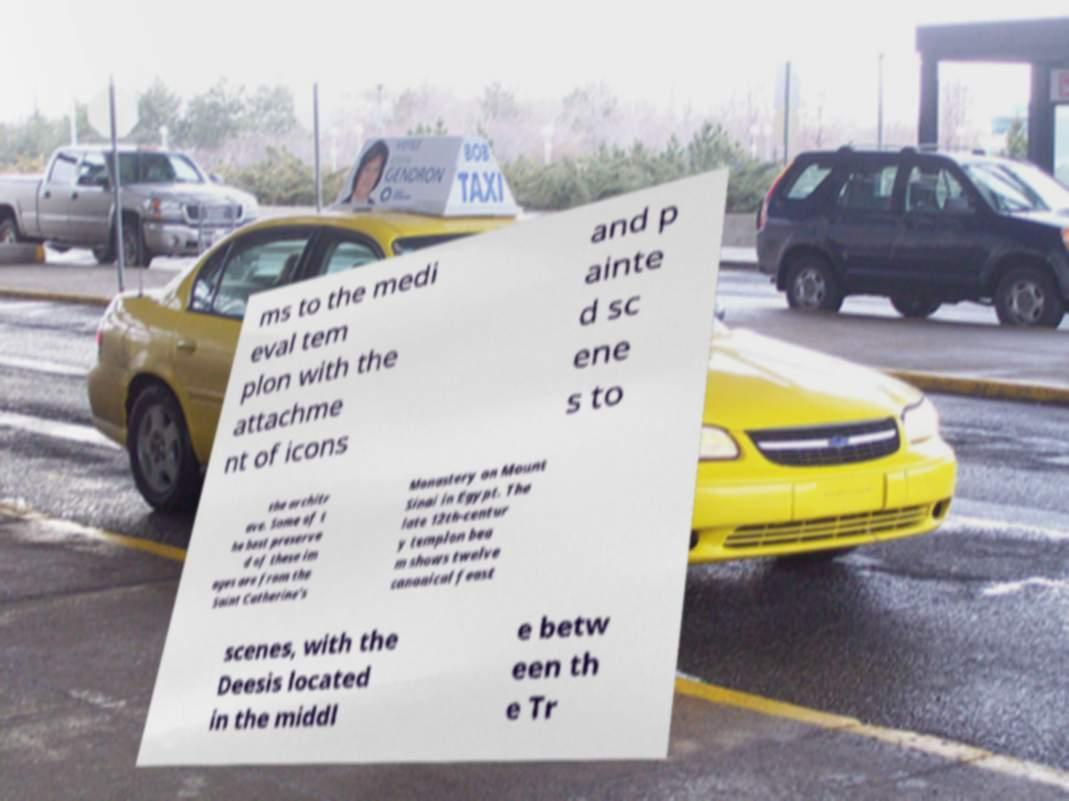I need the written content from this picture converted into text. Can you do that? ms to the medi eval tem plon with the attachme nt of icons and p ainte d sc ene s to the architr ave. Some of t he best preserve d of these im ages are from the Saint Catherine's Monastery on Mount Sinai in Egypt. The late 12th-centur y templon bea m shows twelve canonical feast scenes, with the Deesis located in the middl e betw een th e Tr 